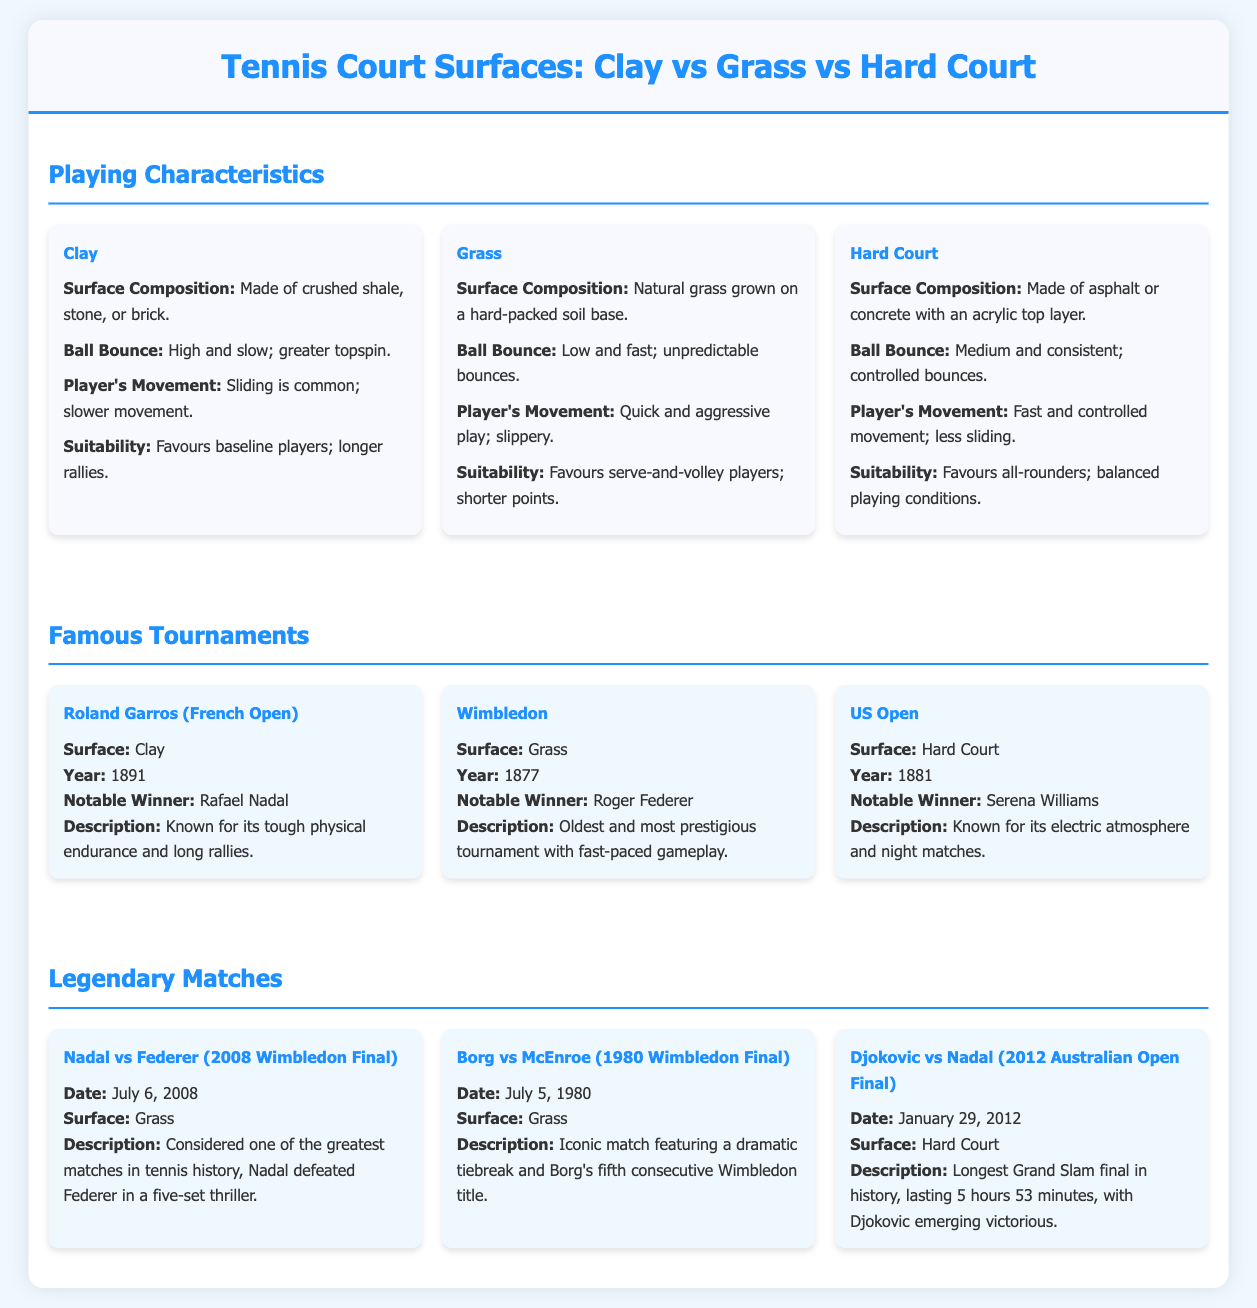What is the surface composition of Clay? The surface composition of Clay is made of crushed shale, stone, or brick.
Answer: Crushed shale, stone, or brick Which famous tournament is held on Grass surface? Wimbledon is the famous tournament held on Grass surface.
Answer: Wimbledon What year did the US Open begin? The US Open began in the year 1881.
Answer: 1881 Who is the notable winner of the Roland Garros? Rafael Nadal is the notable winner of the Roland Garros.
Answer: Rafael Nadal What type of players does Hard Court favor? Hard Court favors all-rounders.
Answer: All-rounders Which two players faced each other in the 2008 Wimbledon Final? Nadal and Federer faced each other in the 2008 Wimbledon Final.
Answer: Nadal and Federer What was the total duration of the longest Grand Slam final? The total duration of the longest Grand Slam final was 5 hours 53 minutes.
Answer: 5 hours 53 minutes What is the description of the Roland Garros tournament? The description states it is known for its tough physical endurance and long rallies.
Answer: Tough physical endurance and long rallies Name one legendary match held on Hard Court. Djokovic vs Nadal (2012 Australian Open Final) is one legendary match held on Hard Court.
Answer: Djokovic vs Nadal (2012 Australian Open Final) 